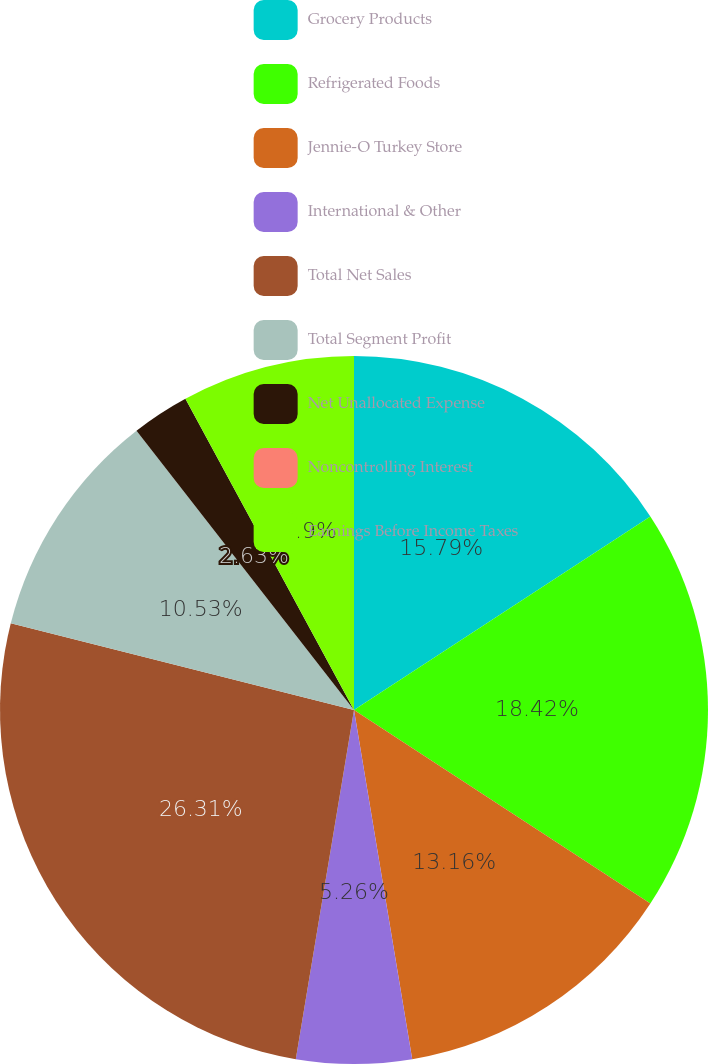Convert chart. <chart><loc_0><loc_0><loc_500><loc_500><pie_chart><fcel>Grocery Products<fcel>Refrigerated Foods<fcel>Jennie-O Turkey Store<fcel>International & Other<fcel>Total Net Sales<fcel>Total Segment Profit<fcel>Net Unallocated Expense<fcel>Noncontrolling Interest<fcel>Earnings Before Income Taxes<nl><fcel>15.79%<fcel>18.42%<fcel>13.16%<fcel>5.26%<fcel>26.31%<fcel>10.53%<fcel>2.63%<fcel>0.0%<fcel>7.9%<nl></chart> 